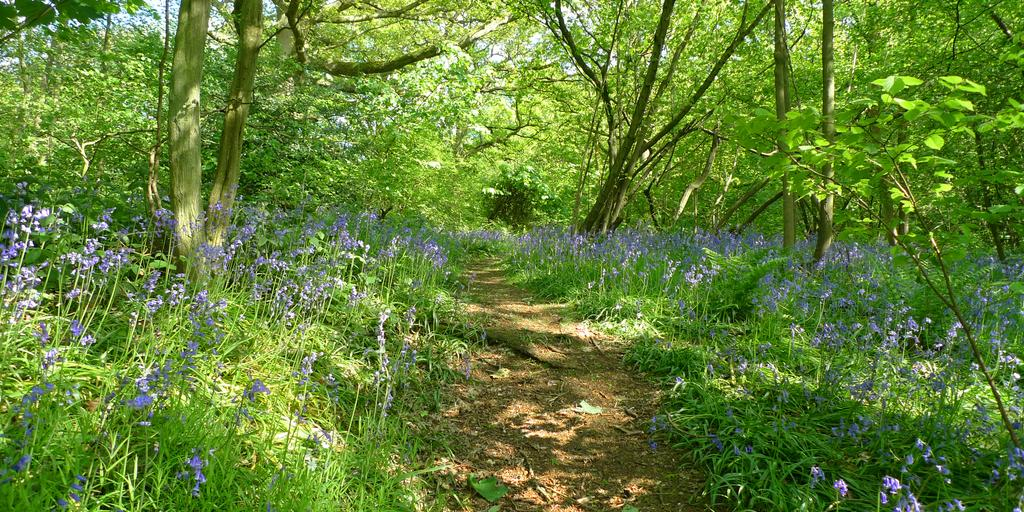What type of vegetation can be seen in the image? There are trees, flowers, and plants in the image. Can you describe the different types of vegetation present? The image contains trees, flowers, and plants. What might be the purpose of the plants in the image? The plants in the image could be for decoration, gardening, or other purposes. How many lizards can be seen washing their hands in the image? There are no lizards present in the image, and therefore no such activity can be observed. 